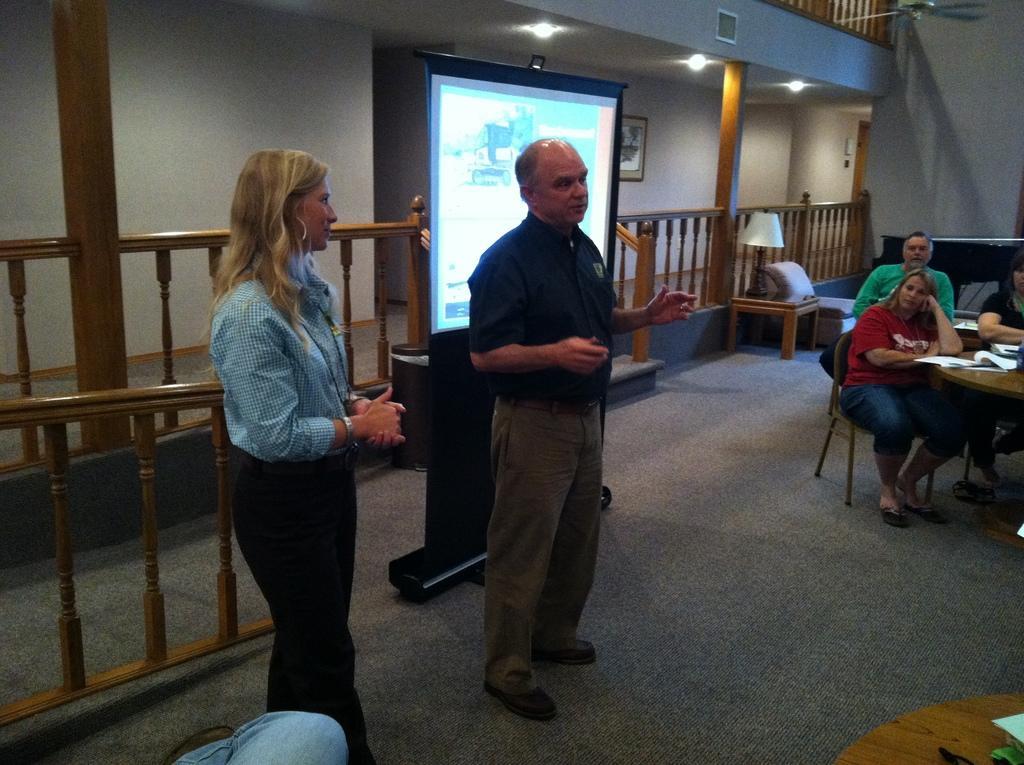Describe this image in one or two sentences. In the foreground of this image, there is a man and a woman standing on the floor. On the bottom, there is a person's leg and a table. In the background, there is a screen, railing, few persons sitting on the chairs near a table, wall, lights and a fan. 